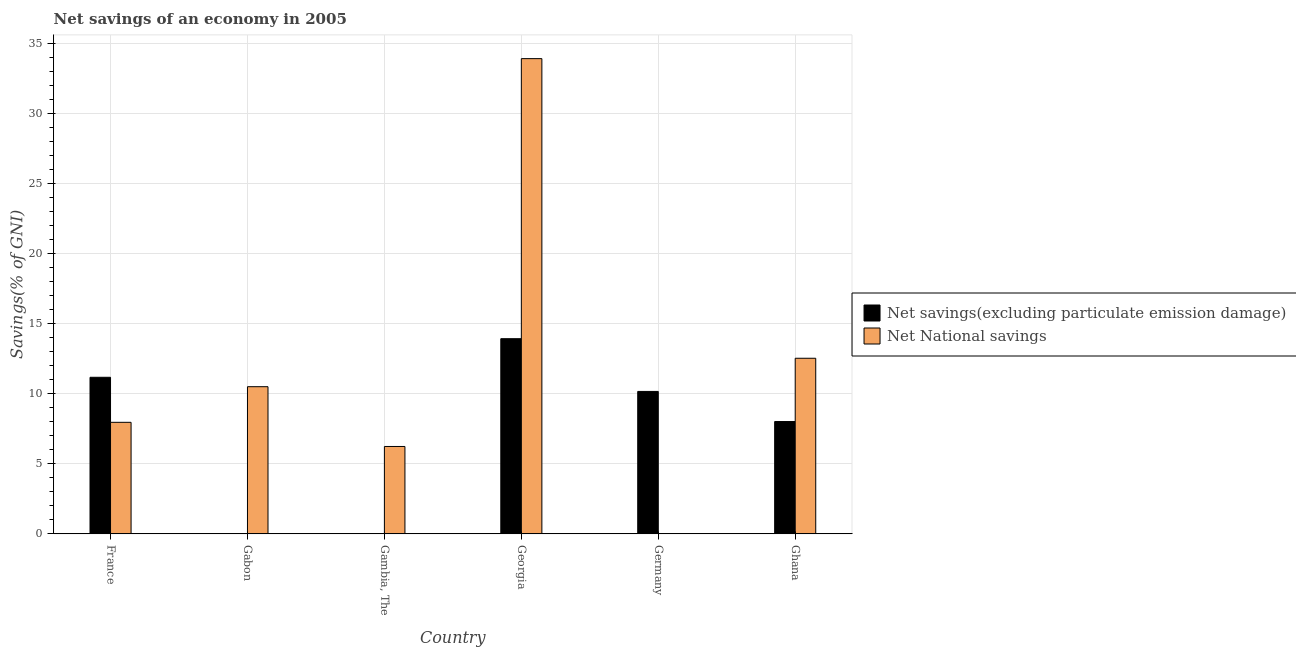How many different coloured bars are there?
Offer a terse response. 2. Are the number of bars per tick equal to the number of legend labels?
Your answer should be compact. No. What is the label of the 6th group of bars from the left?
Give a very brief answer. Ghana. Across all countries, what is the maximum net national savings?
Ensure brevity in your answer.  33.92. In which country was the net national savings maximum?
Ensure brevity in your answer.  Georgia. What is the total net national savings in the graph?
Offer a very short reply. 71.16. What is the difference between the net savings(excluding particulate emission damage) in Georgia and that in Ghana?
Provide a short and direct response. 5.91. What is the difference between the net national savings in Ghana and the net savings(excluding particulate emission damage) in Georgia?
Your response must be concise. -1.4. What is the average net national savings per country?
Your response must be concise. 11.86. What is the difference between the net national savings and net savings(excluding particulate emission damage) in Ghana?
Provide a succinct answer. 4.52. In how many countries, is the net national savings greater than 27 %?
Your answer should be very brief. 1. What is the ratio of the net national savings in Gambia, The to that in Georgia?
Offer a terse response. 0.18. What is the difference between the highest and the second highest net savings(excluding particulate emission damage)?
Your response must be concise. 2.76. What is the difference between the highest and the lowest net savings(excluding particulate emission damage)?
Your answer should be very brief. 13.93. How many bars are there?
Offer a very short reply. 9. How many countries are there in the graph?
Offer a terse response. 6. What is the difference between two consecutive major ticks on the Y-axis?
Your answer should be compact. 5. Are the values on the major ticks of Y-axis written in scientific E-notation?
Make the answer very short. No. Does the graph contain grids?
Make the answer very short. Yes. Where does the legend appear in the graph?
Offer a terse response. Center right. How many legend labels are there?
Give a very brief answer. 2. How are the legend labels stacked?
Make the answer very short. Vertical. What is the title of the graph?
Offer a terse response. Net savings of an economy in 2005. What is the label or title of the X-axis?
Keep it short and to the point. Country. What is the label or title of the Y-axis?
Provide a succinct answer. Savings(% of GNI). What is the Savings(% of GNI) in Net savings(excluding particulate emission damage) in France?
Your response must be concise. 11.18. What is the Savings(% of GNI) of Net National savings in France?
Offer a very short reply. 7.96. What is the Savings(% of GNI) of Net National savings in Gabon?
Offer a very short reply. 10.5. What is the Savings(% of GNI) of Net savings(excluding particulate emission damage) in Gambia, The?
Ensure brevity in your answer.  0. What is the Savings(% of GNI) in Net National savings in Gambia, The?
Offer a terse response. 6.24. What is the Savings(% of GNI) in Net savings(excluding particulate emission damage) in Georgia?
Offer a very short reply. 13.93. What is the Savings(% of GNI) of Net National savings in Georgia?
Your response must be concise. 33.92. What is the Savings(% of GNI) of Net savings(excluding particulate emission damage) in Germany?
Ensure brevity in your answer.  10.17. What is the Savings(% of GNI) of Net savings(excluding particulate emission damage) in Ghana?
Offer a very short reply. 8.02. What is the Savings(% of GNI) of Net National savings in Ghana?
Provide a succinct answer. 12.53. Across all countries, what is the maximum Savings(% of GNI) of Net savings(excluding particulate emission damage)?
Your response must be concise. 13.93. Across all countries, what is the maximum Savings(% of GNI) of Net National savings?
Offer a terse response. 33.92. Across all countries, what is the minimum Savings(% of GNI) in Net savings(excluding particulate emission damage)?
Keep it short and to the point. 0. What is the total Savings(% of GNI) in Net savings(excluding particulate emission damage) in the graph?
Provide a succinct answer. 43.29. What is the total Savings(% of GNI) of Net National savings in the graph?
Make the answer very short. 71.16. What is the difference between the Savings(% of GNI) in Net National savings in France and that in Gabon?
Give a very brief answer. -2.54. What is the difference between the Savings(% of GNI) of Net National savings in France and that in Gambia, The?
Ensure brevity in your answer.  1.72. What is the difference between the Savings(% of GNI) of Net savings(excluding particulate emission damage) in France and that in Georgia?
Ensure brevity in your answer.  -2.76. What is the difference between the Savings(% of GNI) in Net National savings in France and that in Georgia?
Make the answer very short. -25.96. What is the difference between the Savings(% of GNI) of Net savings(excluding particulate emission damage) in France and that in Germany?
Your answer should be compact. 1.01. What is the difference between the Savings(% of GNI) in Net savings(excluding particulate emission damage) in France and that in Ghana?
Make the answer very short. 3.16. What is the difference between the Savings(% of GNI) of Net National savings in France and that in Ghana?
Offer a very short reply. -4.57. What is the difference between the Savings(% of GNI) of Net National savings in Gabon and that in Gambia, The?
Make the answer very short. 4.27. What is the difference between the Savings(% of GNI) in Net National savings in Gabon and that in Georgia?
Your answer should be compact. -23.42. What is the difference between the Savings(% of GNI) of Net National savings in Gabon and that in Ghana?
Your answer should be compact. -2.03. What is the difference between the Savings(% of GNI) in Net National savings in Gambia, The and that in Georgia?
Give a very brief answer. -27.68. What is the difference between the Savings(% of GNI) of Net National savings in Gambia, The and that in Ghana?
Keep it short and to the point. -6.3. What is the difference between the Savings(% of GNI) of Net savings(excluding particulate emission damage) in Georgia and that in Germany?
Offer a terse response. 3.76. What is the difference between the Savings(% of GNI) of Net savings(excluding particulate emission damage) in Georgia and that in Ghana?
Make the answer very short. 5.91. What is the difference between the Savings(% of GNI) of Net National savings in Georgia and that in Ghana?
Your answer should be compact. 21.39. What is the difference between the Savings(% of GNI) in Net savings(excluding particulate emission damage) in Germany and that in Ghana?
Offer a terse response. 2.15. What is the difference between the Savings(% of GNI) in Net savings(excluding particulate emission damage) in France and the Savings(% of GNI) in Net National savings in Gabon?
Keep it short and to the point. 0.67. What is the difference between the Savings(% of GNI) in Net savings(excluding particulate emission damage) in France and the Savings(% of GNI) in Net National savings in Gambia, The?
Ensure brevity in your answer.  4.94. What is the difference between the Savings(% of GNI) of Net savings(excluding particulate emission damage) in France and the Savings(% of GNI) of Net National savings in Georgia?
Your response must be concise. -22.74. What is the difference between the Savings(% of GNI) in Net savings(excluding particulate emission damage) in France and the Savings(% of GNI) in Net National savings in Ghana?
Offer a very short reply. -1.36. What is the difference between the Savings(% of GNI) of Net savings(excluding particulate emission damage) in Georgia and the Savings(% of GNI) of Net National savings in Ghana?
Provide a short and direct response. 1.4. What is the difference between the Savings(% of GNI) in Net savings(excluding particulate emission damage) in Germany and the Savings(% of GNI) in Net National savings in Ghana?
Ensure brevity in your answer.  -2.37. What is the average Savings(% of GNI) of Net savings(excluding particulate emission damage) per country?
Your response must be concise. 7.22. What is the average Savings(% of GNI) in Net National savings per country?
Ensure brevity in your answer.  11.86. What is the difference between the Savings(% of GNI) in Net savings(excluding particulate emission damage) and Savings(% of GNI) in Net National savings in France?
Provide a succinct answer. 3.21. What is the difference between the Savings(% of GNI) of Net savings(excluding particulate emission damage) and Savings(% of GNI) of Net National savings in Georgia?
Provide a succinct answer. -19.99. What is the difference between the Savings(% of GNI) in Net savings(excluding particulate emission damage) and Savings(% of GNI) in Net National savings in Ghana?
Your answer should be compact. -4.52. What is the ratio of the Savings(% of GNI) of Net National savings in France to that in Gabon?
Give a very brief answer. 0.76. What is the ratio of the Savings(% of GNI) in Net National savings in France to that in Gambia, The?
Make the answer very short. 1.28. What is the ratio of the Savings(% of GNI) of Net savings(excluding particulate emission damage) in France to that in Georgia?
Ensure brevity in your answer.  0.8. What is the ratio of the Savings(% of GNI) in Net National savings in France to that in Georgia?
Offer a terse response. 0.23. What is the ratio of the Savings(% of GNI) of Net savings(excluding particulate emission damage) in France to that in Germany?
Provide a succinct answer. 1.1. What is the ratio of the Savings(% of GNI) in Net savings(excluding particulate emission damage) in France to that in Ghana?
Your response must be concise. 1.39. What is the ratio of the Savings(% of GNI) in Net National savings in France to that in Ghana?
Give a very brief answer. 0.64. What is the ratio of the Savings(% of GNI) of Net National savings in Gabon to that in Gambia, The?
Ensure brevity in your answer.  1.68. What is the ratio of the Savings(% of GNI) in Net National savings in Gabon to that in Georgia?
Provide a succinct answer. 0.31. What is the ratio of the Savings(% of GNI) in Net National savings in Gabon to that in Ghana?
Keep it short and to the point. 0.84. What is the ratio of the Savings(% of GNI) of Net National savings in Gambia, The to that in Georgia?
Your response must be concise. 0.18. What is the ratio of the Savings(% of GNI) of Net National savings in Gambia, The to that in Ghana?
Provide a short and direct response. 0.5. What is the ratio of the Savings(% of GNI) of Net savings(excluding particulate emission damage) in Georgia to that in Germany?
Ensure brevity in your answer.  1.37. What is the ratio of the Savings(% of GNI) in Net savings(excluding particulate emission damage) in Georgia to that in Ghana?
Keep it short and to the point. 1.74. What is the ratio of the Savings(% of GNI) of Net National savings in Georgia to that in Ghana?
Make the answer very short. 2.71. What is the ratio of the Savings(% of GNI) in Net savings(excluding particulate emission damage) in Germany to that in Ghana?
Provide a short and direct response. 1.27. What is the difference between the highest and the second highest Savings(% of GNI) in Net savings(excluding particulate emission damage)?
Make the answer very short. 2.76. What is the difference between the highest and the second highest Savings(% of GNI) in Net National savings?
Offer a terse response. 21.39. What is the difference between the highest and the lowest Savings(% of GNI) in Net savings(excluding particulate emission damage)?
Your answer should be very brief. 13.93. What is the difference between the highest and the lowest Savings(% of GNI) of Net National savings?
Provide a short and direct response. 33.92. 